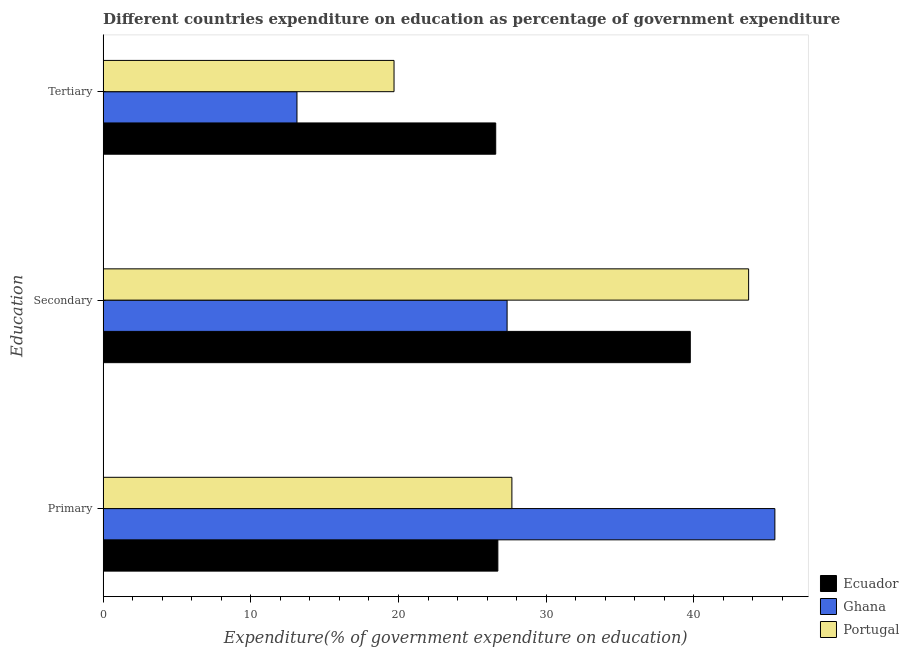How many groups of bars are there?
Offer a terse response. 3. Are the number of bars on each tick of the Y-axis equal?
Keep it short and to the point. Yes. How many bars are there on the 1st tick from the bottom?
Make the answer very short. 3. What is the label of the 3rd group of bars from the top?
Make the answer very short. Primary. What is the expenditure on primary education in Portugal?
Give a very brief answer. 27.68. Across all countries, what is the maximum expenditure on tertiary education?
Your response must be concise. 26.58. Across all countries, what is the minimum expenditure on primary education?
Ensure brevity in your answer.  26.73. In which country was the expenditure on primary education minimum?
Provide a succinct answer. Ecuador. What is the total expenditure on secondary education in the graph?
Give a very brief answer. 110.83. What is the difference between the expenditure on tertiary education in Portugal and that in Ecuador?
Make the answer very short. -6.89. What is the difference between the expenditure on secondary education in Portugal and the expenditure on primary education in Ecuador?
Your answer should be very brief. 16.98. What is the average expenditure on tertiary education per country?
Provide a short and direct response. 19.8. What is the difference between the expenditure on tertiary education and expenditure on primary education in Ghana?
Make the answer very short. -32.36. What is the ratio of the expenditure on secondary education in Ecuador to that in Portugal?
Give a very brief answer. 0.91. Is the expenditure on secondary education in Portugal less than that in Ecuador?
Your answer should be very brief. No. Is the difference between the expenditure on secondary education in Ecuador and Ghana greater than the difference between the expenditure on primary education in Ecuador and Ghana?
Offer a terse response. Yes. What is the difference between the highest and the second highest expenditure on primary education?
Your answer should be compact. 17.81. What is the difference between the highest and the lowest expenditure on primary education?
Provide a short and direct response. 18.76. In how many countries, is the expenditure on secondary education greater than the average expenditure on secondary education taken over all countries?
Make the answer very short. 2. Is the sum of the expenditure on secondary education in Ghana and Portugal greater than the maximum expenditure on tertiary education across all countries?
Make the answer very short. Yes. How many bars are there?
Provide a succinct answer. 9. What is the difference between two consecutive major ticks on the X-axis?
Keep it short and to the point. 10. Does the graph contain any zero values?
Offer a terse response. No. Does the graph contain grids?
Keep it short and to the point. No. What is the title of the graph?
Your response must be concise. Different countries expenditure on education as percentage of government expenditure. What is the label or title of the X-axis?
Make the answer very short. Expenditure(% of government expenditure on education). What is the label or title of the Y-axis?
Your response must be concise. Education. What is the Expenditure(% of government expenditure on education) of Ecuador in Primary?
Make the answer very short. 26.73. What is the Expenditure(% of government expenditure on education) in Ghana in Primary?
Ensure brevity in your answer.  45.49. What is the Expenditure(% of government expenditure on education) of Portugal in Primary?
Your answer should be very brief. 27.68. What is the Expenditure(% of government expenditure on education) in Ecuador in Secondary?
Your answer should be compact. 39.76. What is the Expenditure(% of government expenditure on education) in Ghana in Secondary?
Your response must be concise. 27.36. What is the Expenditure(% of government expenditure on education) of Portugal in Secondary?
Ensure brevity in your answer.  43.71. What is the Expenditure(% of government expenditure on education) in Ecuador in Tertiary?
Offer a terse response. 26.58. What is the Expenditure(% of government expenditure on education) in Ghana in Tertiary?
Offer a very short reply. 13.13. What is the Expenditure(% of government expenditure on education) of Portugal in Tertiary?
Offer a very short reply. 19.7. Across all Education, what is the maximum Expenditure(% of government expenditure on education) of Ecuador?
Make the answer very short. 39.76. Across all Education, what is the maximum Expenditure(% of government expenditure on education) in Ghana?
Your answer should be compact. 45.49. Across all Education, what is the maximum Expenditure(% of government expenditure on education) in Portugal?
Provide a short and direct response. 43.71. Across all Education, what is the minimum Expenditure(% of government expenditure on education) in Ecuador?
Provide a short and direct response. 26.58. Across all Education, what is the minimum Expenditure(% of government expenditure on education) in Ghana?
Offer a terse response. 13.13. Across all Education, what is the minimum Expenditure(% of government expenditure on education) in Portugal?
Make the answer very short. 19.7. What is the total Expenditure(% of government expenditure on education) of Ecuador in the graph?
Your answer should be very brief. 93.07. What is the total Expenditure(% of government expenditure on education) in Ghana in the graph?
Your response must be concise. 85.97. What is the total Expenditure(% of government expenditure on education) of Portugal in the graph?
Offer a terse response. 91.09. What is the difference between the Expenditure(% of government expenditure on education) in Ecuador in Primary and that in Secondary?
Offer a very short reply. -13.03. What is the difference between the Expenditure(% of government expenditure on education) in Ghana in Primary and that in Secondary?
Your response must be concise. 18.13. What is the difference between the Expenditure(% of government expenditure on education) in Portugal in Primary and that in Secondary?
Ensure brevity in your answer.  -16.03. What is the difference between the Expenditure(% of government expenditure on education) of Ecuador in Primary and that in Tertiary?
Make the answer very short. 0.14. What is the difference between the Expenditure(% of government expenditure on education) in Ghana in Primary and that in Tertiary?
Give a very brief answer. 32.36. What is the difference between the Expenditure(% of government expenditure on education) of Portugal in Primary and that in Tertiary?
Your answer should be very brief. 7.98. What is the difference between the Expenditure(% of government expenditure on education) of Ecuador in Secondary and that in Tertiary?
Provide a short and direct response. 13.18. What is the difference between the Expenditure(% of government expenditure on education) in Ghana in Secondary and that in Tertiary?
Provide a succinct answer. 14.23. What is the difference between the Expenditure(% of government expenditure on education) in Portugal in Secondary and that in Tertiary?
Provide a short and direct response. 24.01. What is the difference between the Expenditure(% of government expenditure on education) in Ecuador in Primary and the Expenditure(% of government expenditure on education) in Ghana in Secondary?
Your response must be concise. -0.63. What is the difference between the Expenditure(% of government expenditure on education) of Ecuador in Primary and the Expenditure(% of government expenditure on education) of Portugal in Secondary?
Offer a very short reply. -16.98. What is the difference between the Expenditure(% of government expenditure on education) in Ghana in Primary and the Expenditure(% of government expenditure on education) in Portugal in Secondary?
Your answer should be very brief. 1.78. What is the difference between the Expenditure(% of government expenditure on education) in Ecuador in Primary and the Expenditure(% of government expenditure on education) in Ghana in Tertiary?
Your answer should be compact. 13.6. What is the difference between the Expenditure(% of government expenditure on education) in Ecuador in Primary and the Expenditure(% of government expenditure on education) in Portugal in Tertiary?
Make the answer very short. 7.03. What is the difference between the Expenditure(% of government expenditure on education) in Ghana in Primary and the Expenditure(% of government expenditure on education) in Portugal in Tertiary?
Offer a very short reply. 25.79. What is the difference between the Expenditure(% of government expenditure on education) of Ecuador in Secondary and the Expenditure(% of government expenditure on education) of Ghana in Tertiary?
Ensure brevity in your answer.  26.63. What is the difference between the Expenditure(% of government expenditure on education) in Ecuador in Secondary and the Expenditure(% of government expenditure on education) in Portugal in Tertiary?
Provide a short and direct response. 20.06. What is the difference between the Expenditure(% of government expenditure on education) of Ghana in Secondary and the Expenditure(% of government expenditure on education) of Portugal in Tertiary?
Ensure brevity in your answer.  7.66. What is the average Expenditure(% of government expenditure on education) of Ecuador per Education?
Give a very brief answer. 31.02. What is the average Expenditure(% of government expenditure on education) in Ghana per Education?
Provide a succinct answer. 28.66. What is the average Expenditure(% of government expenditure on education) of Portugal per Education?
Give a very brief answer. 30.36. What is the difference between the Expenditure(% of government expenditure on education) in Ecuador and Expenditure(% of government expenditure on education) in Ghana in Primary?
Give a very brief answer. -18.76. What is the difference between the Expenditure(% of government expenditure on education) in Ecuador and Expenditure(% of government expenditure on education) in Portugal in Primary?
Provide a succinct answer. -0.95. What is the difference between the Expenditure(% of government expenditure on education) of Ghana and Expenditure(% of government expenditure on education) of Portugal in Primary?
Your response must be concise. 17.81. What is the difference between the Expenditure(% of government expenditure on education) in Ecuador and Expenditure(% of government expenditure on education) in Ghana in Secondary?
Your response must be concise. 12.41. What is the difference between the Expenditure(% of government expenditure on education) of Ecuador and Expenditure(% of government expenditure on education) of Portugal in Secondary?
Your answer should be compact. -3.95. What is the difference between the Expenditure(% of government expenditure on education) in Ghana and Expenditure(% of government expenditure on education) in Portugal in Secondary?
Your answer should be very brief. -16.36. What is the difference between the Expenditure(% of government expenditure on education) of Ecuador and Expenditure(% of government expenditure on education) of Ghana in Tertiary?
Offer a very short reply. 13.46. What is the difference between the Expenditure(% of government expenditure on education) of Ecuador and Expenditure(% of government expenditure on education) of Portugal in Tertiary?
Offer a terse response. 6.89. What is the difference between the Expenditure(% of government expenditure on education) in Ghana and Expenditure(% of government expenditure on education) in Portugal in Tertiary?
Provide a succinct answer. -6.57. What is the ratio of the Expenditure(% of government expenditure on education) in Ecuador in Primary to that in Secondary?
Your answer should be very brief. 0.67. What is the ratio of the Expenditure(% of government expenditure on education) of Ghana in Primary to that in Secondary?
Provide a short and direct response. 1.66. What is the ratio of the Expenditure(% of government expenditure on education) of Portugal in Primary to that in Secondary?
Your response must be concise. 0.63. What is the ratio of the Expenditure(% of government expenditure on education) in Ecuador in Primary to that in Tertiary?
Your answer should be compact. 1.01. What is the ratio of the Expenditure(% of government expenditure on education) in Ghana in Primary to that in Tertiary?
Your answer should be compact. 3.47. What is the ratio of the Expenditure(% of government expenditure on education) of Portugal in Primary to that in Tertiary?
Your answer should be very brief. 1.41. What is the ratio of the Expenditure(% of government expenditure on education) in Ecuador in Secondary to that in Tertiary?
Provide a short and direct response. 1.5. What is the ratio of the Expenditure(% of government expenditure on education) in Ghana in Secondary to that in Tertiary?
Your answer should be compact. 2.08. What is the ratio of the Expenditure(% of government expenditure on education) in Portugal in Secondary to that in Tertiary?
Make the answer very short. 2.22. What is the difference between the highest and the second highest Expenditure(% of government expenditure on education) in Ecuador?
Keep it short and to the point. 13.03. What is the difference between the highest and the second highest Expenditure(% of government expenditure on education) of Ghana?
Offer a terse response. 18.13. What is the difference between the highest and the second highest Expenditure(% of government expenditure on education) of Portugal?
Offer a very short reply. 16.03. What is the difference between the highest and the lowest Expenditure(% of government expenditure on education) of Ecuador?
Your answer should be compact. 13.18. What is the difference between the highest and the lowest Expenditure(% of government expenditure on education) in Ghana?
Ensure brevity in your answer.  32.36. What is the difference between the highest and the lowest Expenditure(% of government expenditure on education) in Portugal?
Your response must be concise. 24.01. 